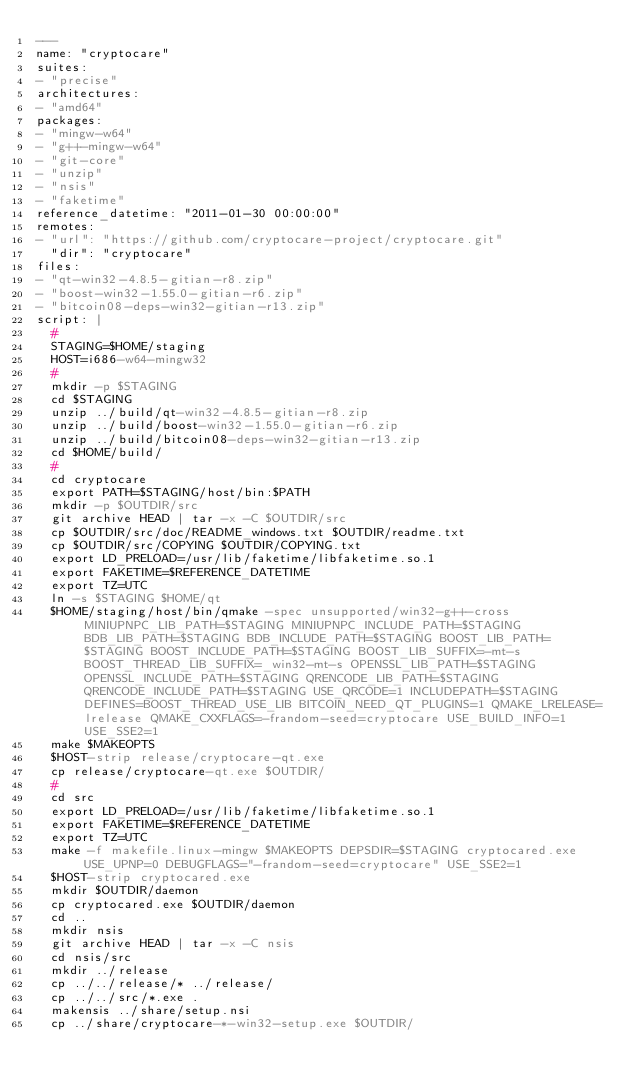<code> <loc_0><loc_0><loc_500><loc_500><_YAML_>---
name: "cryptocare"
suites:
- "precise"
architectures:
- "amd64"
packages:
- "mingw-w64"
- "g++-mingw-w64"
- "git-core"
- "unzip"
- "nsis"
- "faketime"
reference_datetime: "2011-01-30 00:00:00"
remotes:
- "url": "https://github.com/cryptocare-project/cryptocare.git"
  "dir": "cryptocare"
files:
- "qt-win32-4.8.5-gitian-r8.zip"
- "boost-win32-1.55.0-gitian-r6.zip"
- "bitcoin08-deps-win32-gitian-r13.zip"
script: |
  #
  STAGING=$HOME/staging
  HOST=i686-w64-mingw32
  #
  mkdir -p $STAGING
  cd $STAGING
  unzip ../build/qt-win32-4.8.5-gitian-r8.zip
  unzip ../build/boost-win32-1.55.0-gitian-r6.zip
  unzip ../build/bitcoin08-deps-win32-gitian-r13.zip
  cd $HOME/build/
  #
  cd cryptocare
  export PATH=$STAGING/host/bin:$PATH
  mkdir -p $OUTDIR/src
  git archive HEAD | tar -x -C $OUTDIR/src
  cp $OUTDIR/src/doc/README_windows.txt $OUTDIR/readme.txt
  cp $OUTDIR/src/COPYING $OUTDIR/COPYING.txt
  export LD_PRELOAD=/usr/lib/faketime/libfaketime.so.1
  export FAKETIME=$REFERENCE_DATETIME
  export TZ=UTC
  ln -s $STAGING $HOME/qt
  $HOME/staging/host/bin/qmake -spec unsupported/win32-g++-cross MINIUPNPC_LIB_PATH=$STAGING MINIUPNPC_INCLUDE_PATH=$STAGING BDB_LIB_PATH=$STAGING BDB_INCLUDE_PATH=$STAGING BOOST_LIB_PATH=$STAGING BOOST_INCLUDE_PATH=$STAGING BOOST_LIB_SUFFIX=-mt-s BOOST_THREAD_LIB_SUFFIX=_win32-mt-s OPENSSL_LIB_PATH=$STAGING OPENSSL_INCLUDE_PATH=$STAGING QRENCODE_LIB_PATH=$STAGING QRENCODE_INCLUDE_PATH=$STAGING USE_QRCODE=1 INCLUDEPATH=$STAGING DEFINES=BOOST_THREAD_USE_LIB BITCOIN_NEED_QT_PLUGINS=1 QMAKE_LRELEASE=lrelease QMAKE_CXXFLAGS=-frandom-seed=cryptocare USE_BUILD_INFO=1 USE_SSE2=1
  make $MAKEOPTS
  $HOST-strip release/cryptocare-qt.exe
  cp release/cryptocare-qt.exe $OUTDIR/
  #
  cd src
  export LD_PRELOAD=/usr/lib/faketime/libfaketime.so.1
  export FAKETIME=$REFERENCE_DATETIME
  export TZ=UTC
  make -f makefile.linux-mingw $MAKEOPTS DEPSDIR=$STAGING cryptocared.exe USE_UPNP=0 DEBUGFLAGS="-frandom-seed=cryptocare" USE_SSE2=1
  $HOST-strip cryptocared.exe
  mkdir $OUTDIR/daemon
  cp cryptocared.exe $OUTDIR/daemon
  cd ..
  mkdir nsis
  git archive HEAD | tar -x -C nsis
  cd nsis/src
  mkdir ../release
  cp ../../release/* ../release/
  cp ../../src/*.exe .
  makensis ../share/setup.nsi
  cp ../share/cryptocare-*-win32-setup.exe $OUTDIR/
</code> 